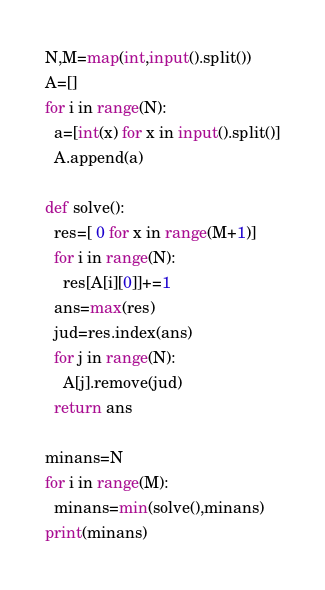<code> <loc_0><loc_0><loc_500><loc_500><_Python_>N,M=map(int,input().split())
A=[]
for i in range(N):
  a=[int(x) for x in input().split()]
  A.append(a)
  
def solve():
  res=[ 0 for x in range(M+1)]
  for i in range(N):
    res[A[i][0]]+=1
  ans=max(res)
  jud=res.index(ans)
  for j in range(N):
    A[j].remove(jud)
  return ans

minans=N
for i in range(M):
  minans=min(solve(),minans)
print(minans)</code> 